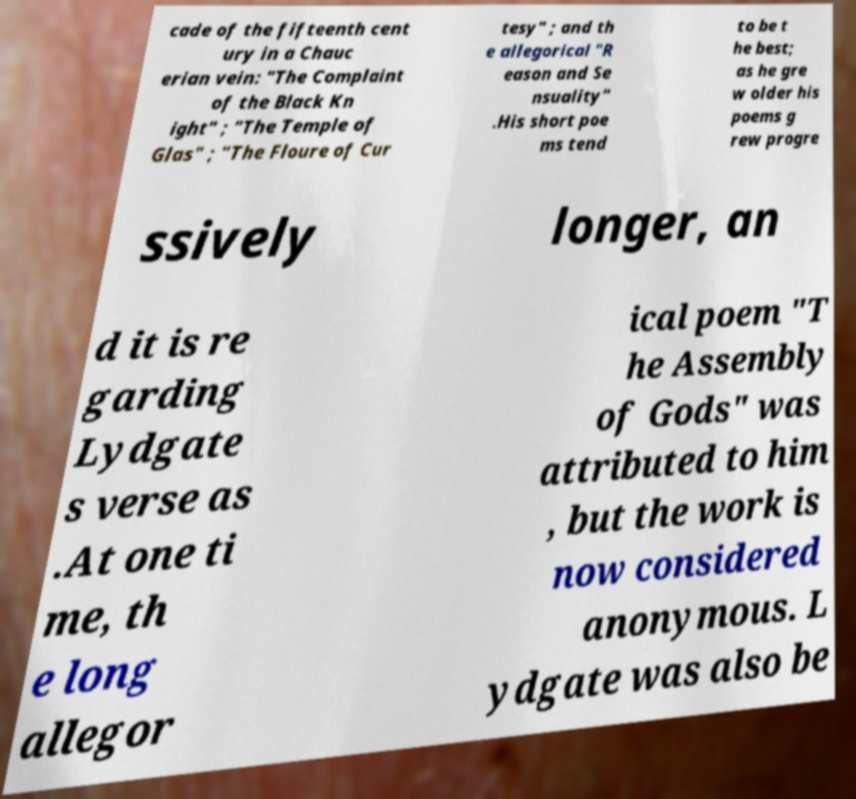Please read and relay the text visible in this image. What does it say? cade of the fifteenth cent ury in a Chauc erian vein: "The Complaint of the Black Kn ight" ; "The Temple of Glas" ; "The Floure of Cur tesy" ; and th e allegorical "R eason and Se nsuality" .His short poe ms tend to be t he best; as he gre w older his poems g rew progre ssively longer, an d it is re garding Lydgate s verse as .At one ti me, th e long allegor ical poem "T he Assembly of Gods" was attributed to him , but the work is now considered anonymous. L ydgate was also be 